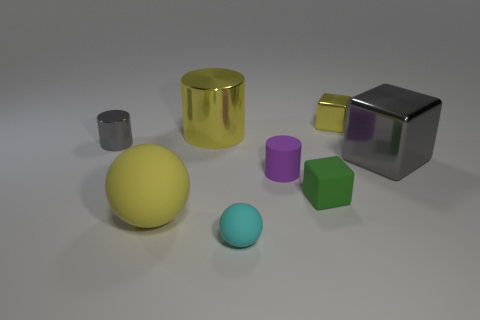What number of small cubes have the same color as the big cylinder?
Provide a short and direct response. 1. There is a big object that is the same color as the large ball; what is it made of?
Provide a short and direct response. Metal. There is a tiny metallic cylinder; is it the same color as the big object that is right of the tiny purple rubber object?
Offer a terse response. Yes. Do the big matte object and the large shiny cylinder have the same color?
Provide a succinct answer. Yes. How big is the metallic thing that is both on the left side of the green matte cube and to the right of the tiny gray cylinder?
Your answer should be compact. Large. There is a small thing that is both on the right side of the purple matte object and behind the small rubber cylinder; what color is it?
Ensure brevity in your answer.  Yellow. Are there fewer rubber balls that are on the left side of the small cyan thing than objects that are in front of the large gray metallic cube?
Your response must be concise. Yes. What number of other objects have the same shape as the tiny green object?
Offer a terse response. 2. There is a yellow cylinder that is made of the same material as the gray cube; what is its size?
Offer a very short reply. Large. The rubber ball that is in front of the rubber ball behind the cyan matte thing is what color?
Keep it short and to the point. Cyan. 